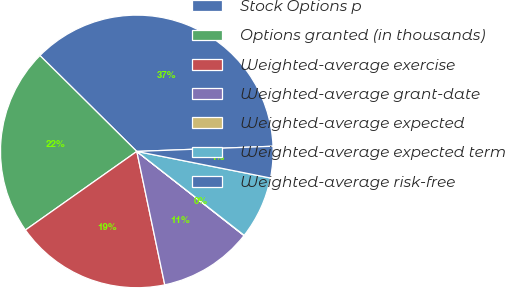Convert chart to OTSL. <chart><loc_0><loc_0><loc_500><loc_500><pie_chart><fcel>Stock Options p<fcel>Options granted (in thousands)<fcel>Weighted-average exercise<fcel>Weighted-average grant-date<fcel>Weighted-average expected<fcel>Weighted-average expected term<fcel>Weighted-average risk-free<nl><fcel>36.98%<fcel>22.2%<fcel>18.51%<fcel>11.12%<fcel>0.04%<fcel>7.43%<fcel>3.73%<nl></chart> 